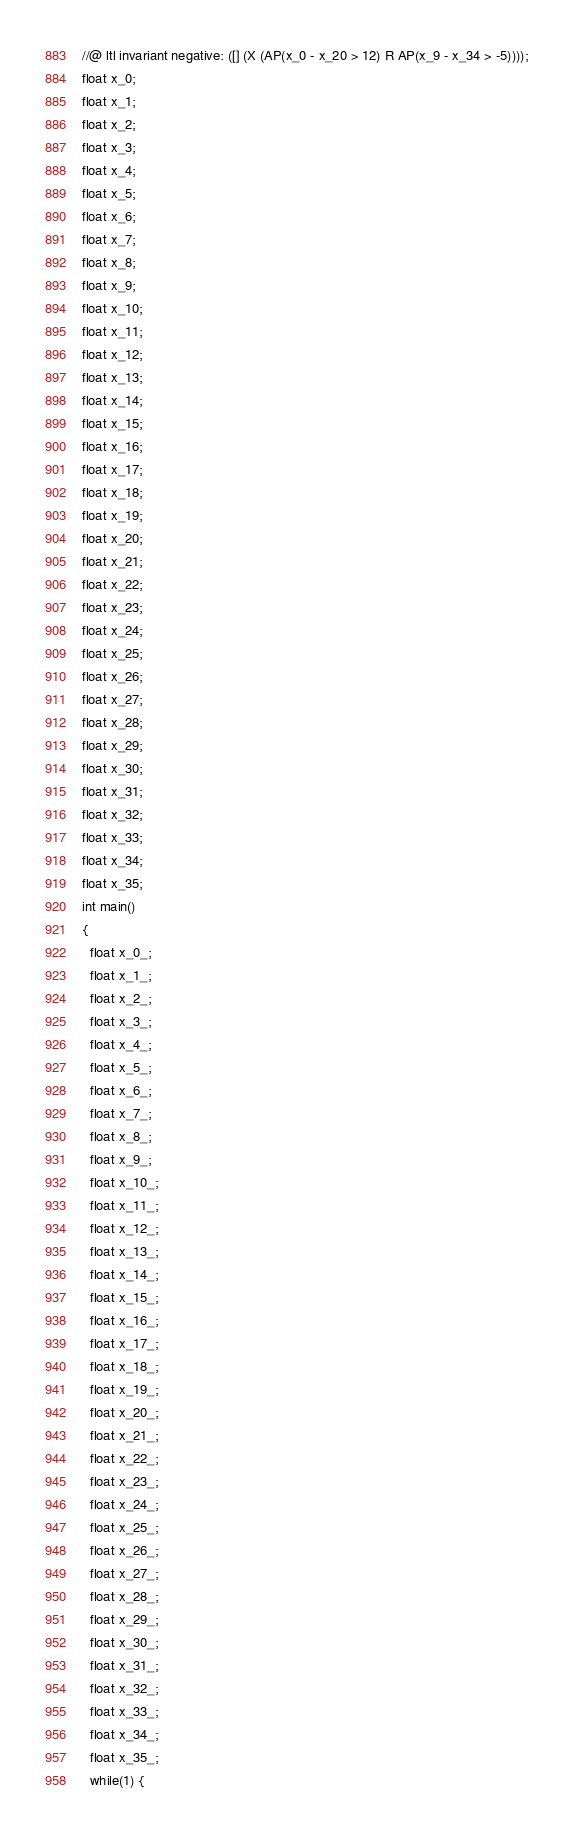<code> <loc_0><loc_0><loc_500><loc_500><_C_>//@ ltl invariant negative: ([] (X (AP(x_0 - x_20 > 12) R AP(x_9 - x_34 > -5))));
float x_0;
float x_1;
float x_2;
float x_3;
float x_4;
float x_5;
float x_6;
float x_7;
float x_8;
float x_9;
float x_10;
float x_11;
float x_12;
float x_13;
float x_14;
float x_15;
float x_16;
float x_17;
float x_18;
float x_19;
float x_20;
float x_21;
float x_22;
float x_23;
float x_24;
float x_25;
float x_26;
float x_27;
float x_28;
float x_29;
float x_30;
float x_31;
float x_32;
float x_33;
float x_34;
float x_35;
int main()
{
  float x_0_;
  float x_1_;
  float x_2_;
  float x_3_;
  float x_4_;
  float x_5_;
  float x_6_;
  float x_7_;
  float x_8_;
  float x_9_;
  float x_10_;
  float x_11_;
  float x_12_;
  float x_13_;
  float x_14_;
  float x_15_;
  float x_16_;
  float x_17_;
  float x_18_;
  float x_19_;
  float x_20_;
  float x_21_;
  float x_22_;
  float x_23_;
  float x_24_;
  float x_25_;
  float x_26_;
  float x_27_;
  float x_28_;
  float x_29_;
  float x_30_;
  float x_31_;
  float x_32_;
  float x_33_;
  float x_34_;
  float x_35_;
  while(1) {</code> 